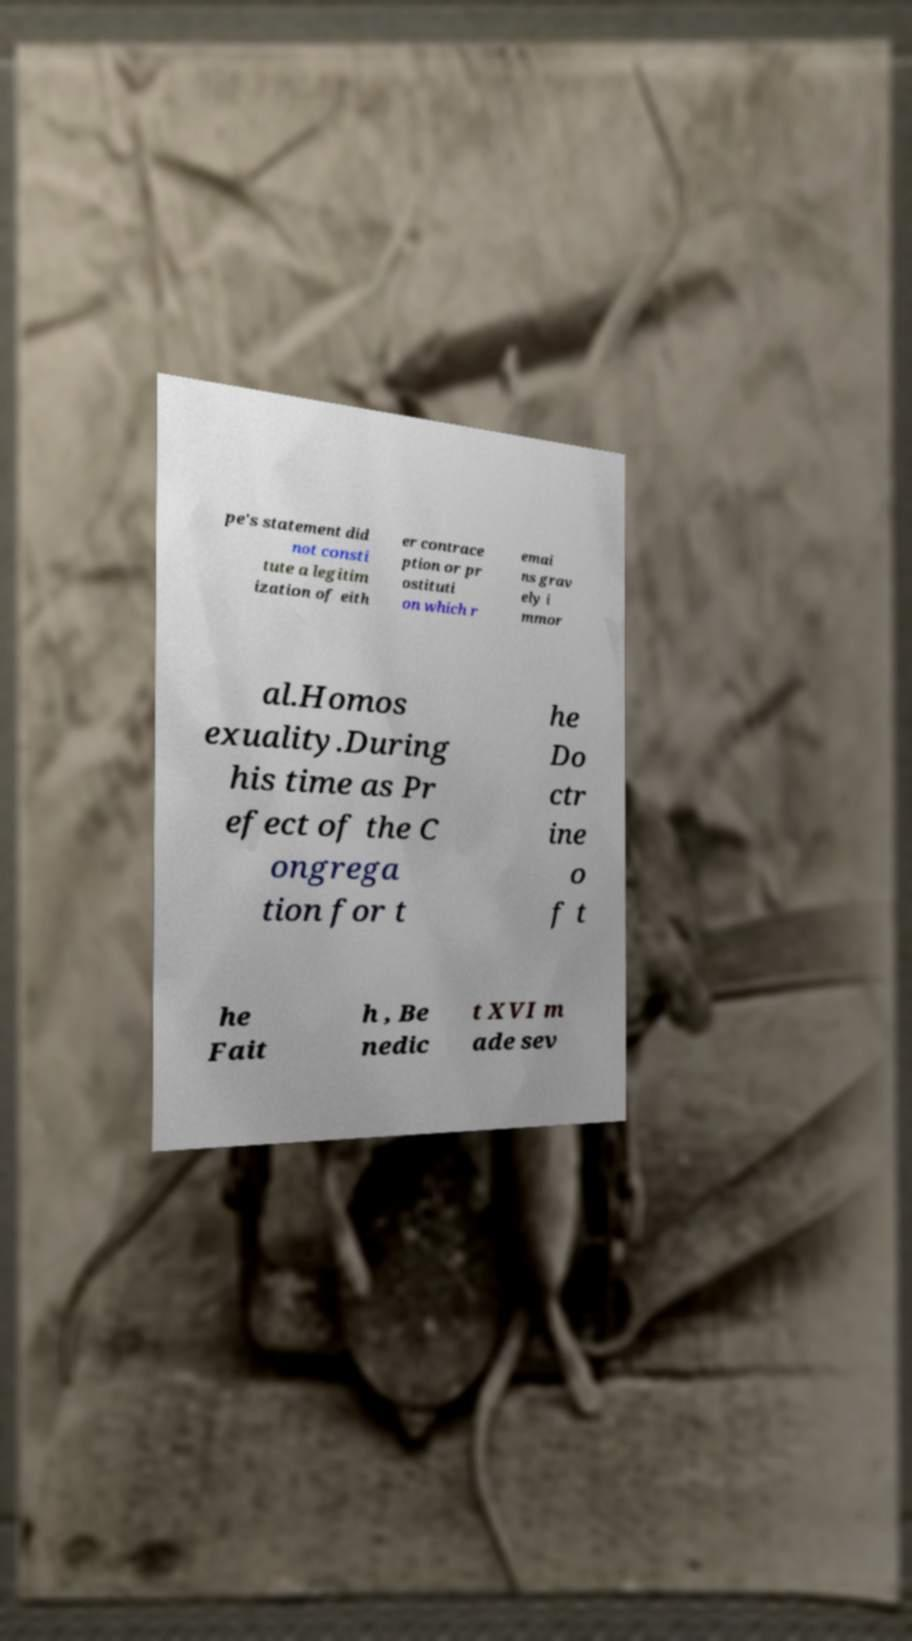Could you assist in decoding the text presented in this image and type it out clearly? pe's statement did not consti tute a legitim ization of eith er contrace ption or pr ostituti on which r emai ns grav ely i mmor al.Homos exuality.During his time as Pr efect of the C ongrega tion for t he Do ctr ine o f t he Fait h , Be nedic t XVI m ade sev 